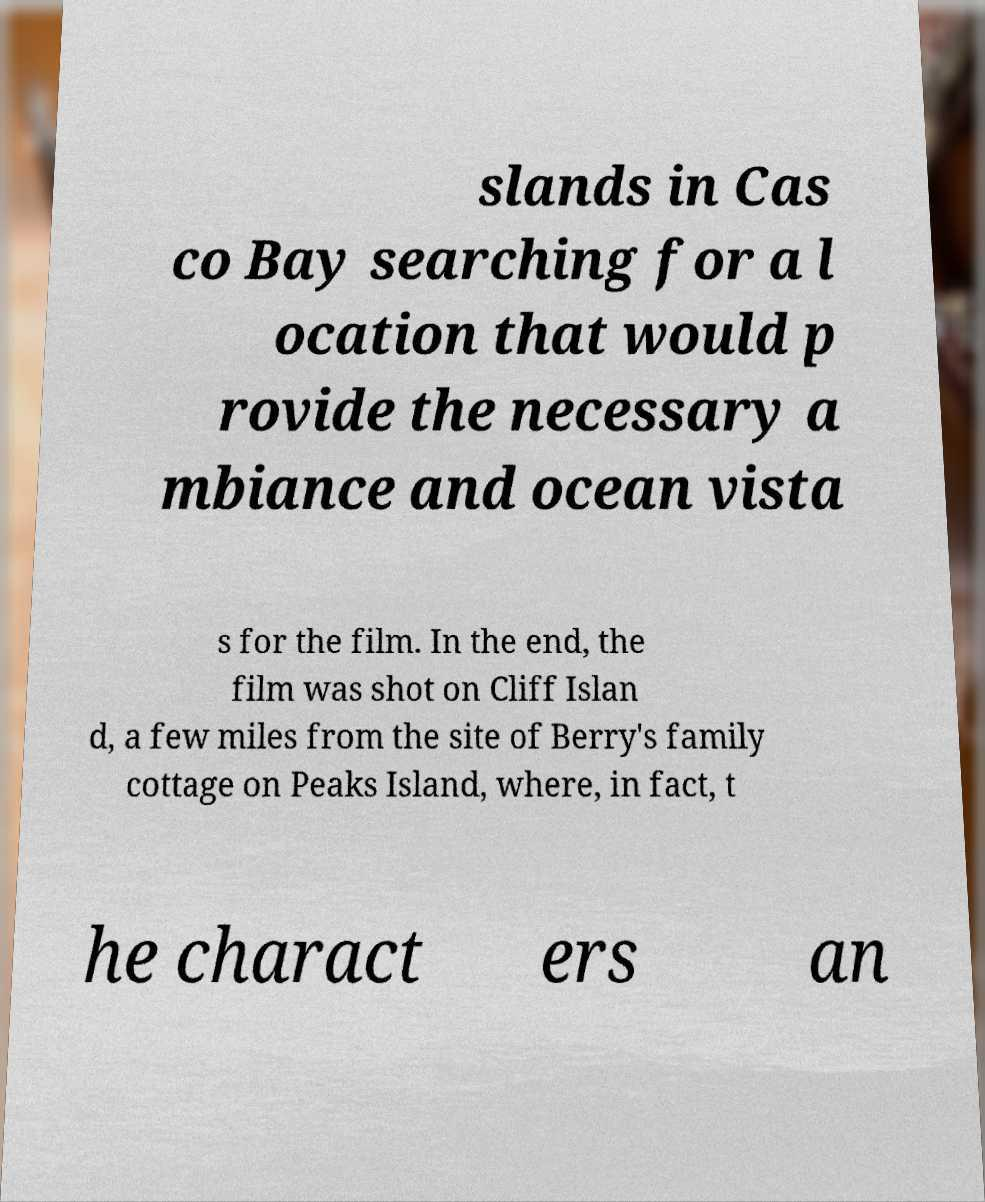Can you read and provide the text displayed in the image?This photo seems to have some interesting text. Can you extract and type it out for me? slands in Cas co Bay searching for a l ocation that would p rovide the necessary a mbiance and ocean vista s for the film. In the end, the film was shot on Cliff Islan d, a few miles from the site of Berry's family cottage on Peaks Island, where, in fact, t he charact ers an 